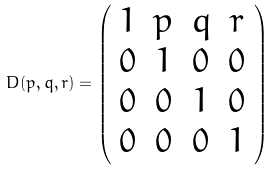<formula> <loc_0><loc_0><loc_500><loc_500>D ( p , q , r ) = \left ( \begin{array} { c c c c } { 1 } & { p } & { q } & { r } \\ { 0 } & { 1 } & { 0 } & { 0 } \\ { 0 } & { 0 } & { 1 } & { 0 } \\ { 0 } & { 0 } & { 0 } & { 1 } \end{array} \right )</formula> 